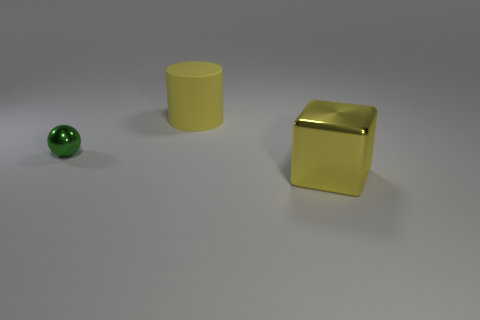Add 3 green objects. How many objects exist? 6 Subtract all balls. How many objects are left? 2 Subtract all big matte things. Subtract all large metallic blocks. How many objects are left? 1 Add 2 green balls. How many green balls are left? 3 Add 1 big metallic blocks. How many big metallic blocks exist? 2 Subtract 0 gray cylinders. How many objects are left? 3 